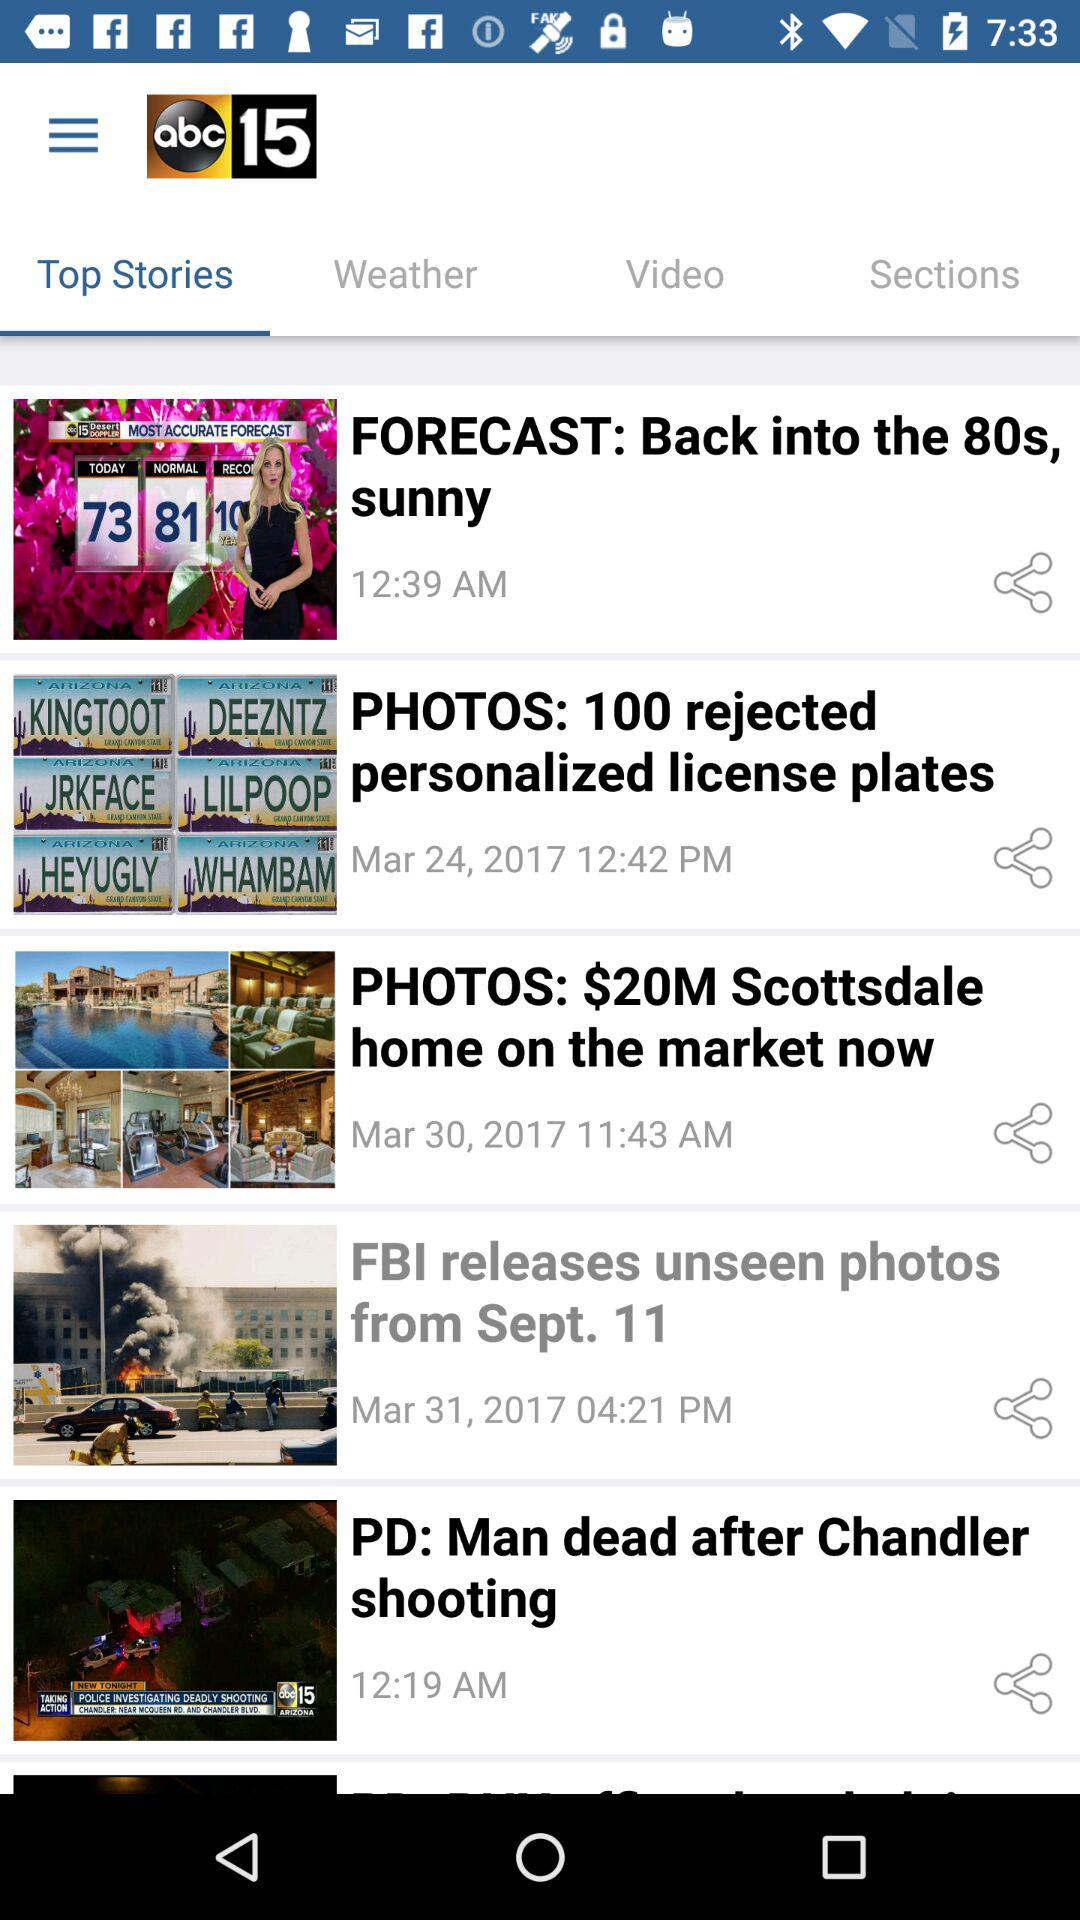Which tab is selected? The selected tab is "Top Stories". 